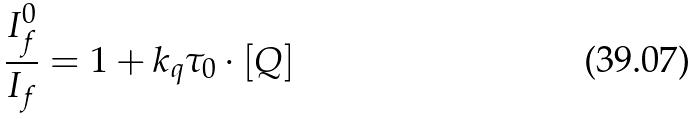Convert formula to latex. <formula><loc_0><loc_0><loc_500><loc_500>\frac { I _ { f } ^ { 0 } } { I _ { f } } = 1 + k _ { q } \tau _ { 0 } \cdot [ Q ]</formula> 